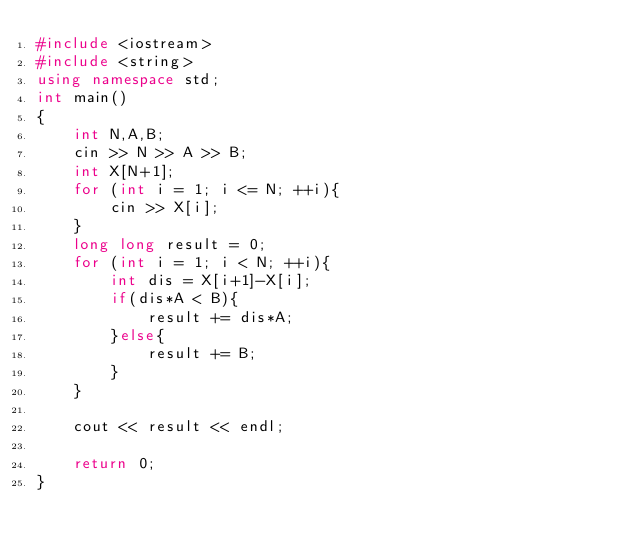<code> <loc_0><loc_0><loc_500><loc_500><_C++_>#include <iostream>
#include <string>
using namespace std;
int main()
{
    int N,A,B;
    cin >> N >> A >> B;
    int X[N+1];
    for (int i = 1; i <= N; ++i){
        cin >> X[i];
    }
    long long result = 0;
    for (int i = 1; i < N; ++i){
        int dis = X[i+1]-X[i];
        if(dis*A < B){
            result += dis*A;
        }else{
            result += B;
        }
    }
    
    cout << result << endl;
    
    return 0;
}</code> 